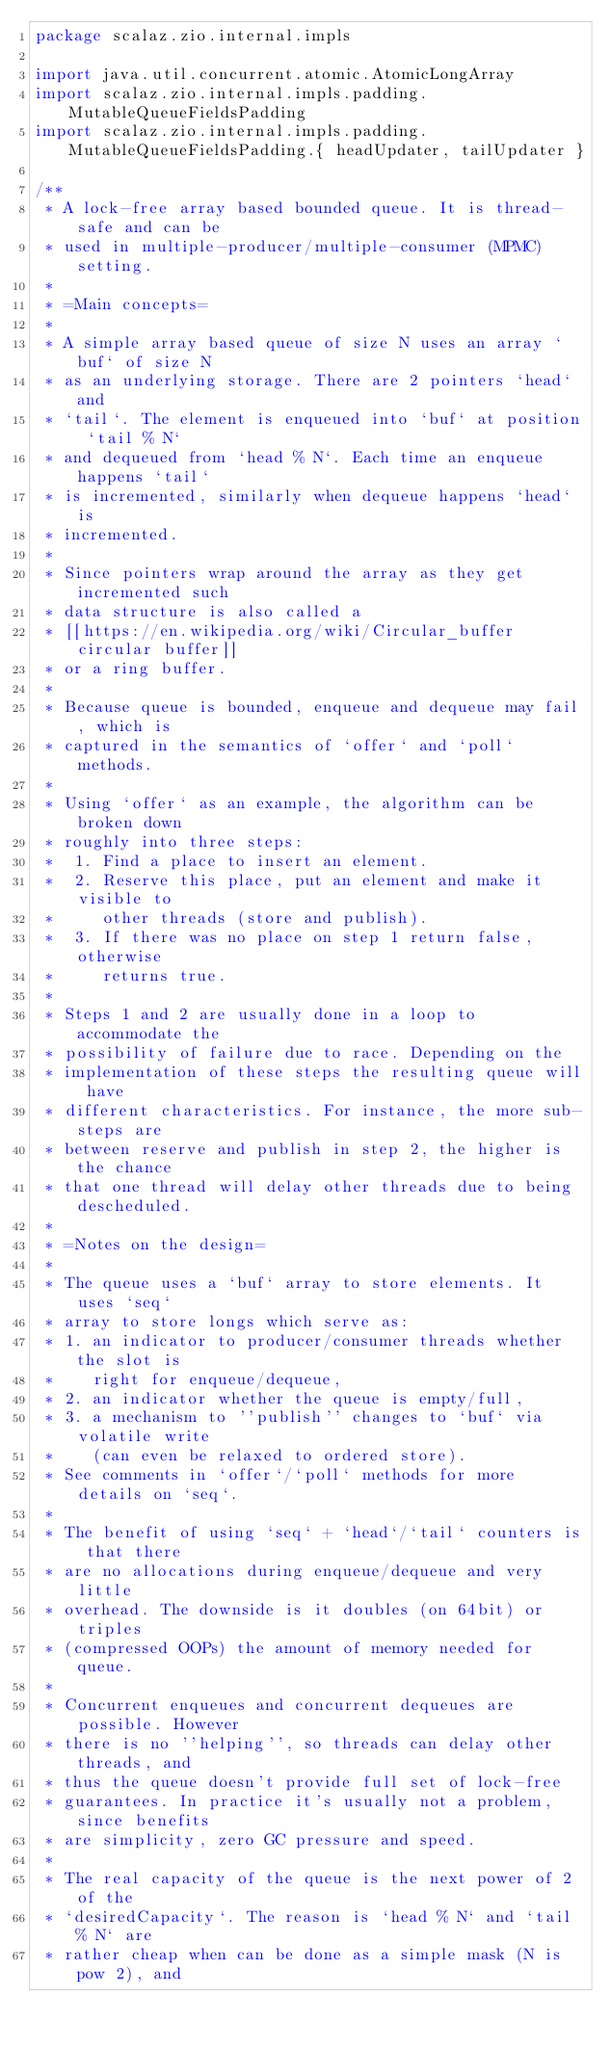<code> <loc_0><loc_0><loc_500><loc_500><_Scala_>package scalaz.zio.internal.impls

import java.util.concurrent.atomic.AtomicLongArray
import scalaz.zio.internal.impls.padding.MutableQueueFieldsPadding
import scalaz.zio.internal.impls.padding.MutableQueueFieldsPadding.{ headUpdater, tailUpdater }

/**
 * A lock-free array based bounded queue. It is thread-safe and can be
 * used in multiple-producer/multiple-consumer (MPMC) setting.
 *
 * =Main concepts=
 *
 * A simple array based queue of size N uses an array `buf` of size N
 * as an underlying storage. There are 2 pointers `head` and
 * `tail`. The element is enqueued into `buf` at position `tail % N`
 * and dequeued from `head % N`. Each time an enqueue happens `tail`
 * is incremented, similarly when dequeue happens `head` is
 * incremented.
 *
 * Since pointers wrap around the array as they get incremented such
 * data structure is also called a
 * [[https://en.wikipedia.org/wiki/Circular_buffer circular buffer]]
 * or a ring buffer.
 *
 * Because queue is bounded, enqueue and dequeue may fail, which is
 * captured in the semantics of `offer` and `poll` methods.
 *
 * Using `offer` as an example, the algorithm can be broken down
 * roughly into three steps:
 *  1. Find a place to insert an element.
 *  2. Reserve this place, put an element and make it visible to
 *     other threads (store and publish).
 *  3. If there was no place on step 1 return false, otherwise
 *     returns true.
 *
 * Steps 1 and 2 are usually done in a loop to accommodate the
 * possibility of failure due to race. Depending on the
 * implementation of these steps the resulting queue will have
 * different characteristics. For instance, the more sub-steps are
 * between reserve and publish in step 2, the higher is the chance
 * that one thread will delay other threads due to being descheduled.
 *
 * =Notes on the design=
 *
 * The queue uses a `buf` array to store elements. It uses `seq`
 * array to store longs which serve as:
 * 1. an indicator to producer/consumer threads whether the slot is
 *    right for enqueue/dequeue,
 * 2. an indicator whether the queue is empty/full,
 * 3. a mechanism to ''publish'' changes to `buf` via volatile write
 *    (can even be relaxed to ordered store).
 * See comments in `offer`/`poll` methods for more details on `seq`.
 *
 * The benefit of using `seq` + `head`/`tail` counters is that there
 * are no allocations during enqueue/dequeue and very little
 * overhead. The downside is it doubles (on 64bit) or triples
 * (compressed OOPs) the amount of memory needed for queue.
 *
 * Concurrent enqueues and concurrent dequeues are possible. However
 * there is no ''helping'', so threads can delay other threads, and
 * thus the queue doesn't provide full set of lock-free
 * guarantees. In practice it's usually not a problem, since benefits
 * are simplicity, zero GC pressure and speed.
 *
 * The real capacity of the queue is the next power of 2 of the
 * `desiredCapacity`. The reason is `head % N` and `tail % N` are
 * rather cheap when can be done as a simple mask (N is pow 2), and</code> 